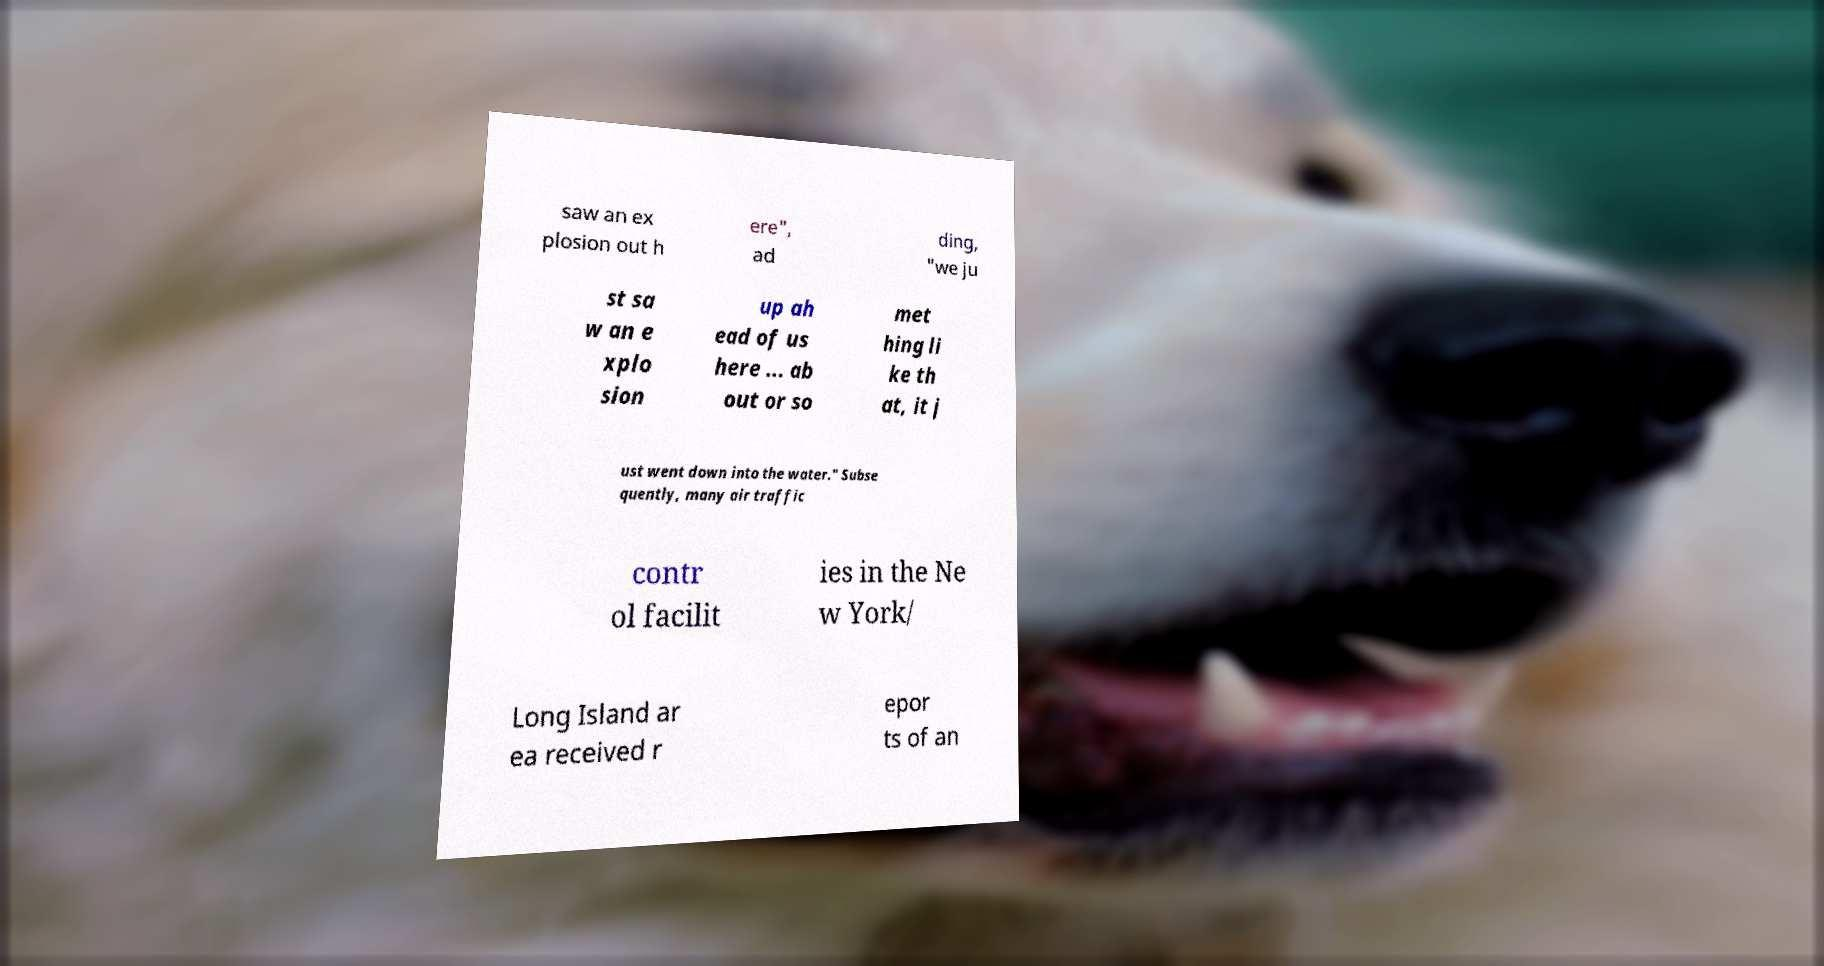Could you extract and type out the text from this image? saw an ex plosion out h ere", ad ding, "we ju st sa w an e xplo sion up ah ead of us here ... ab out or so met hing li ke th at, it j ust went down into the water." Subse quently, many air traffic contr ol facilit ies in the Ne w York/ Long Island ar ea received r epor ts of an 